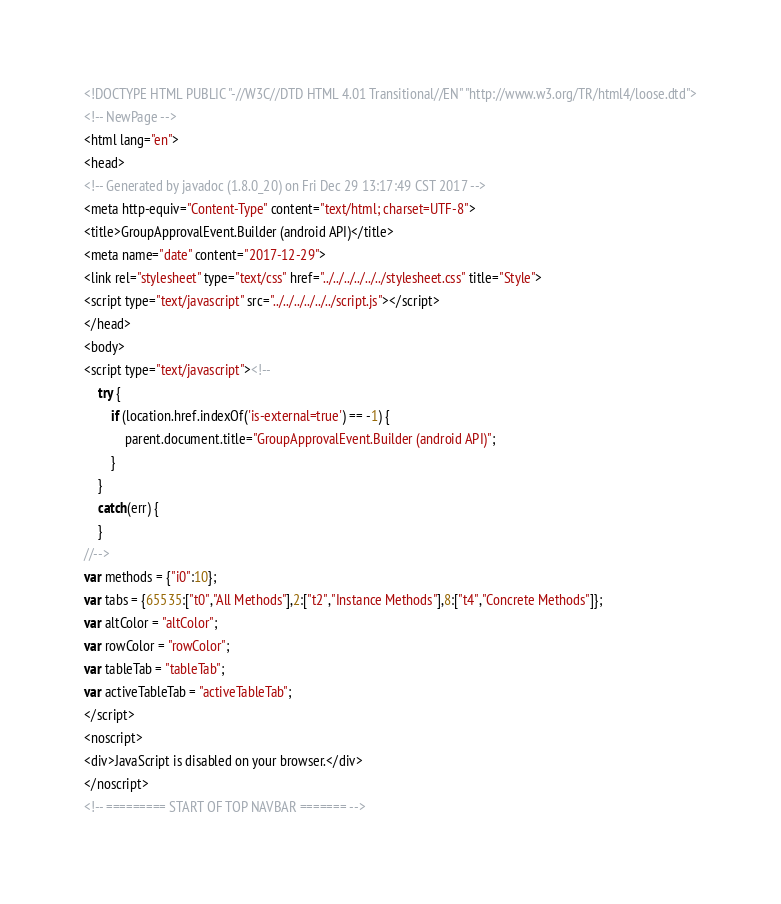Convert code to text. <code><loc_0><loc_0><loc_500><loc_500><_HTML_><!DOCTYPE HTML PUBLIC "-//W3C//DTD HTML 4.01 Transitional//EN" "http://www.w3.org/TR/html4/loose.dtd">
<!-- NewPage -->
<html lang="en">
<head>
<!-- Generated by javadoc (1.8.0_20) on Fri Dec 29 13:17:49 CST 2017 -->
<meta http-equiv="Content-Type" content="text/html; charset=UTF-8">
<title>GroupApprovalEvent.Builder (android API)</title>
<meta name="date" content="2017-12-29">
<link rel="stylesheet" type="text/css" href="../../../../../../stylesheet.css" title="Style">
<script type="text/javascript" src="../../../../../../script.js"></script>
</head>
<body>
<script type="text/javascript"><!--
    try {
        if (location.href.indexOf('is-external=true') == -1) {
            parent.document.title="GroupApprovalEvent.Builder (android API)";
        }
    }
    catch(err) {
    }
//-->
var methods = {"i0":10};
var tabs = {65535:["t0","All Methods"],2:["t2","Instance Methods"],8:["t4","Concrete Methods"]};
var altColor = "altColor";
var rowColor = "rowColor";
var tableTab = "tableTab";
var activeTableTab = "activeTableTab";
</script>
<noscript>
<div>JavaScript is disabled on your browser.</div>
</noscript>
<!-- ========= START OF TOP NAVBAR ======= --></code> 